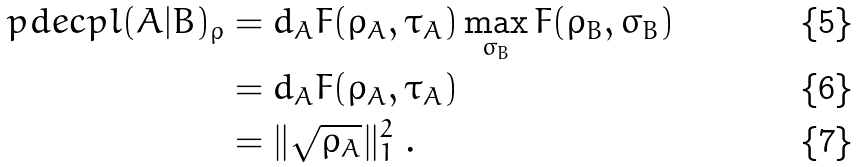Convert formula to latex. <formula><loc_0><loc_0><loc_500><loc_500>\ p d e c p l ( A | B ) _ { \rho } & = d _ { A } F ( \rho _ { A } , \tau _ { A } ) \max _ { \sigma _ { B } } F ( \rho _ { B } , \sigma _ { B } ) \\ & = d _ { A } F ( \rho _ { A } , \tau _ { A } ) \\ & = \| \sqrt { \rho _ { A } } \| _ { 1 } ^ { 2 } \ .</formula> 